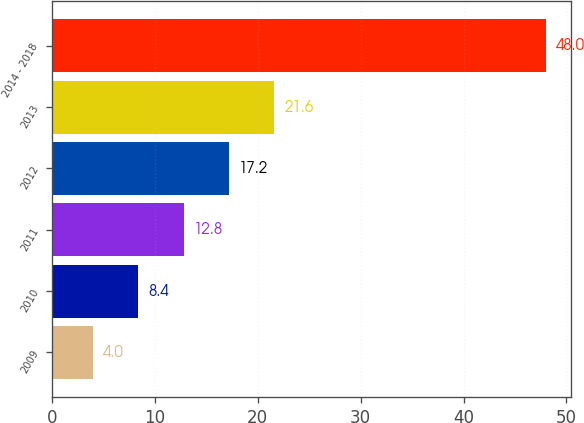Convert chart to OTSL. <chart><loc_0><loc_0><loc_500><loc_500><bar_chart><fcel>2009<fcel>2010<fcel>2011<fcel>2012<fcel>2013<fcel>2014 - 2018<nl><fcel>4<fcel>8.4<fcel>12.8<fcel>17.2<fcel>21.6<fcel>48<nl></chart> 